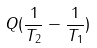Convert formula to latex. <formula><loc_0><loc_0><loc_500><loc_500>Q ( \frac { 1 } { T _ { 2 } } - \frac { 1 } { T _ { 1 } } )</formula> 